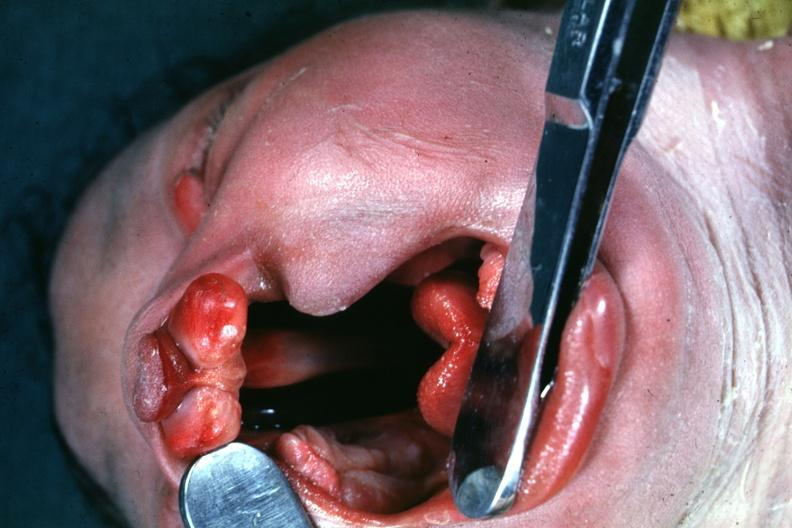s bilateral cleft palate present?
Answer the question using a single word or phrase. Yes 